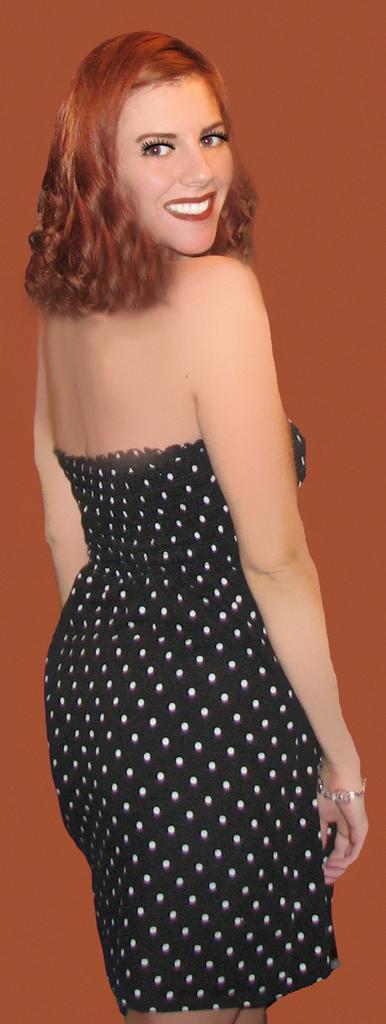Could you give a brief overview of what you see in this image? In this image we can see a lady, and the background is orange in color. 